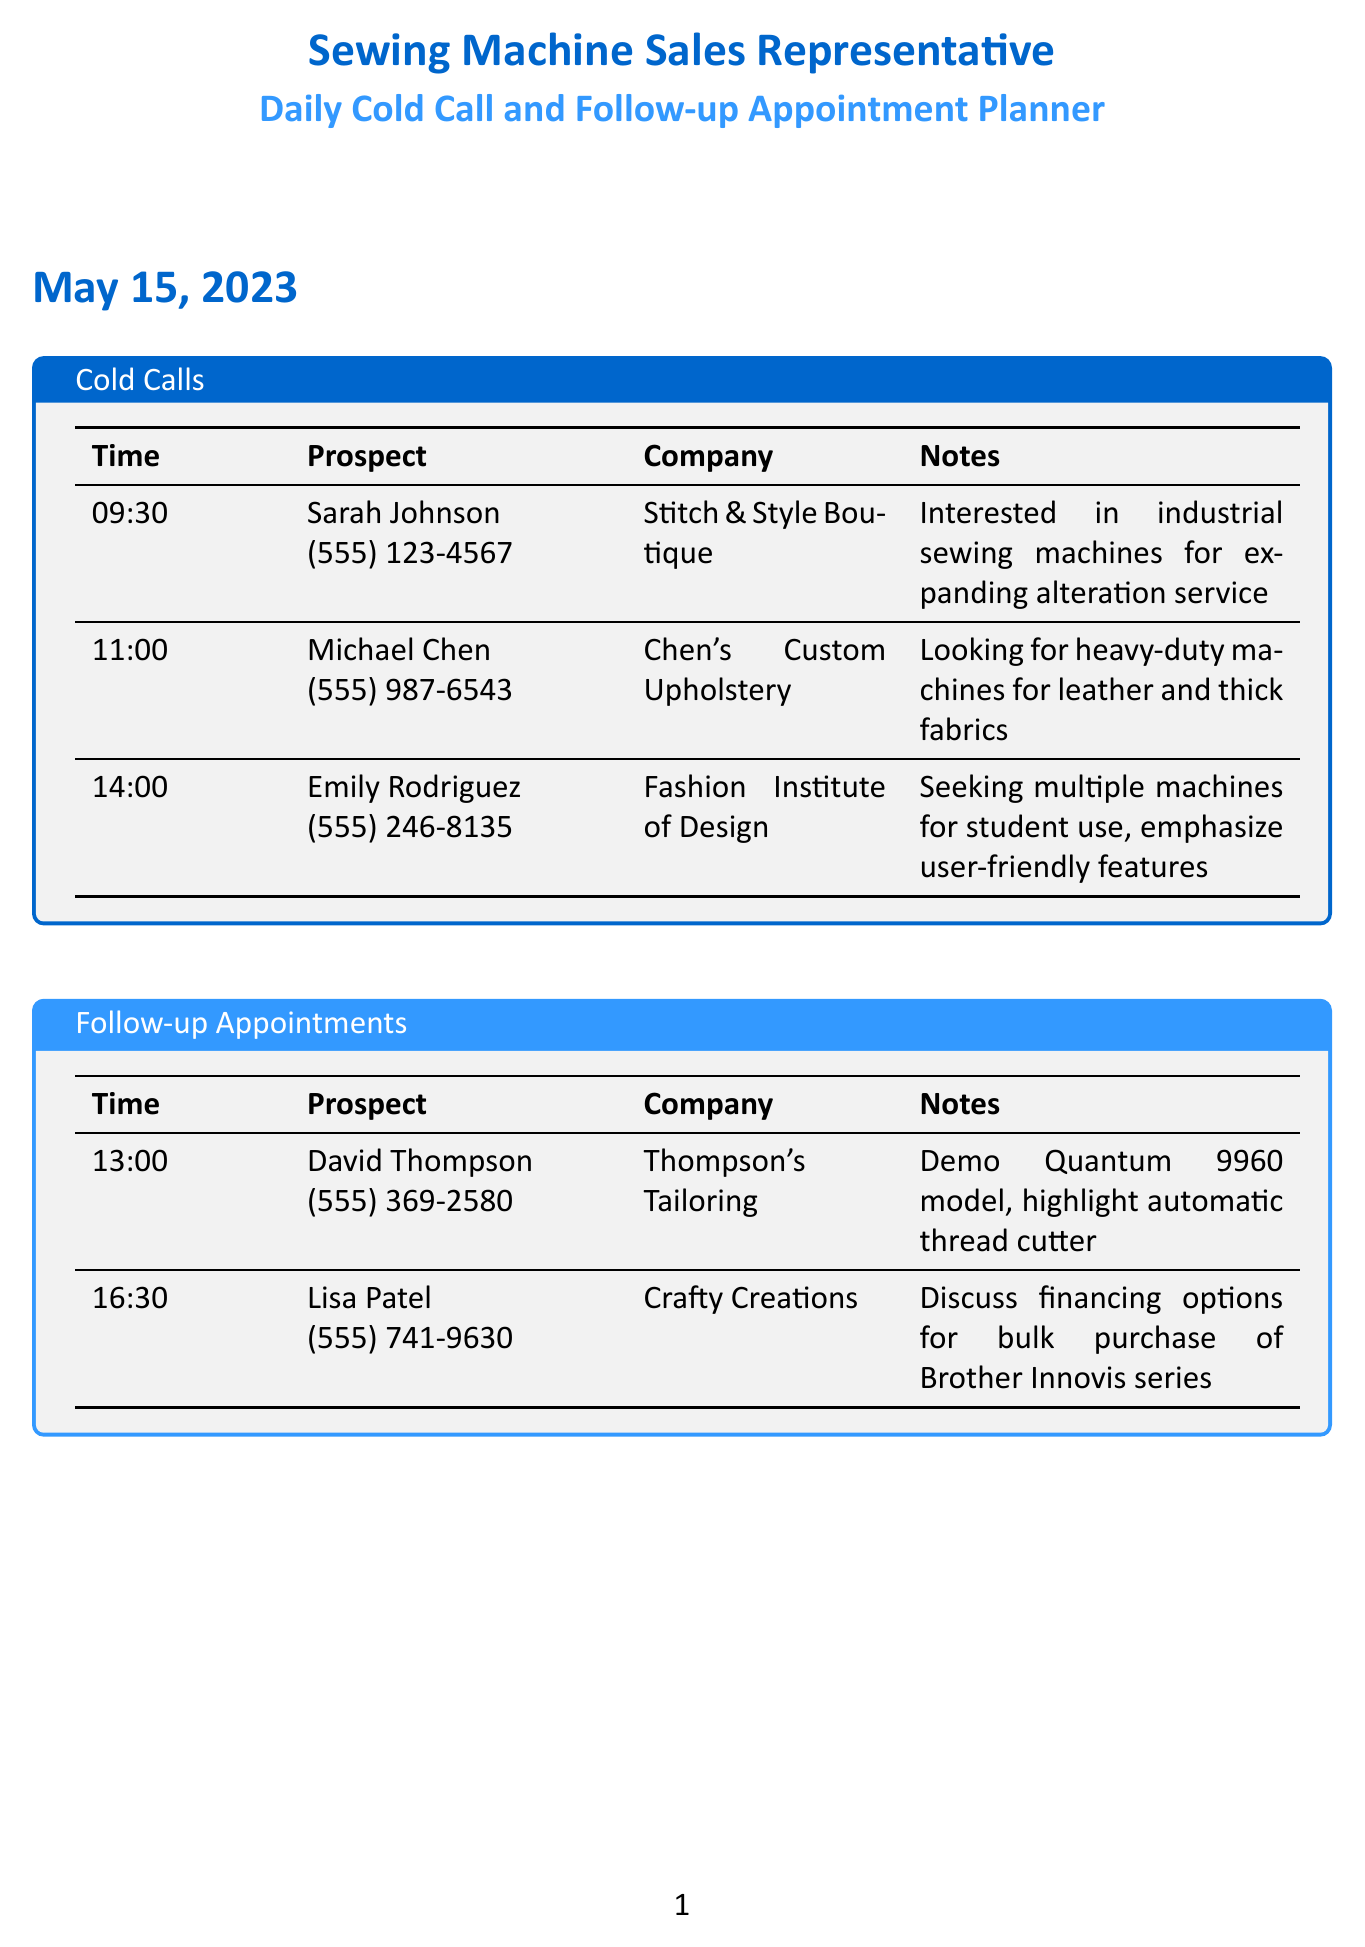what is the name of the first prospect on May 15, 2023? The first prospect listed on May 15, 2023, is Sarah Johnson.
Answer: Sarah Johnson what is the time for the follow-up appointment with David Thompson? The appointment with David Thompson is scheduled for 1:00 PM.
Answer: 1:00 PM how many cold calls are scheduled for May 16, 2023? There are three cold calls scheduled on May 16, 2023.
Answer: 3 what is the phone number of Lisa Patel? Lisa Patel's phone number is (555) 741-9630.
Answer: (555) 741-9630 which company is interested in industrial sewing machines for an alteration service? Stitch & Style Boutique is interested in industrial sewing machines for their alteration service.
Answer: Stitch & Style Boutique which model is to be demonstrated to Michael Chen during the follow-up? The Singer 4423 Heavy Duty model is to be demonstrated to Michael Chen.
Answer: Singer 4423 Heavy Duty what specific feature should be highlighted for the follow-up with David Thompson? The automatic thread cutter feature should be highlighted for the follow-up with David Thompson.
Answer: automatic thread cutter who will be called at 10:00 AM on May 16, 2023? Robert Garcia will be called at 10:00 AM on May 16, 2023.
Answer: Robert Garcia what is the main selling point for the machines aimed at the Fashion Institute of Design? The main selling point is the emphasis on user-friendly features for student use.
Answer: user-friendly features 